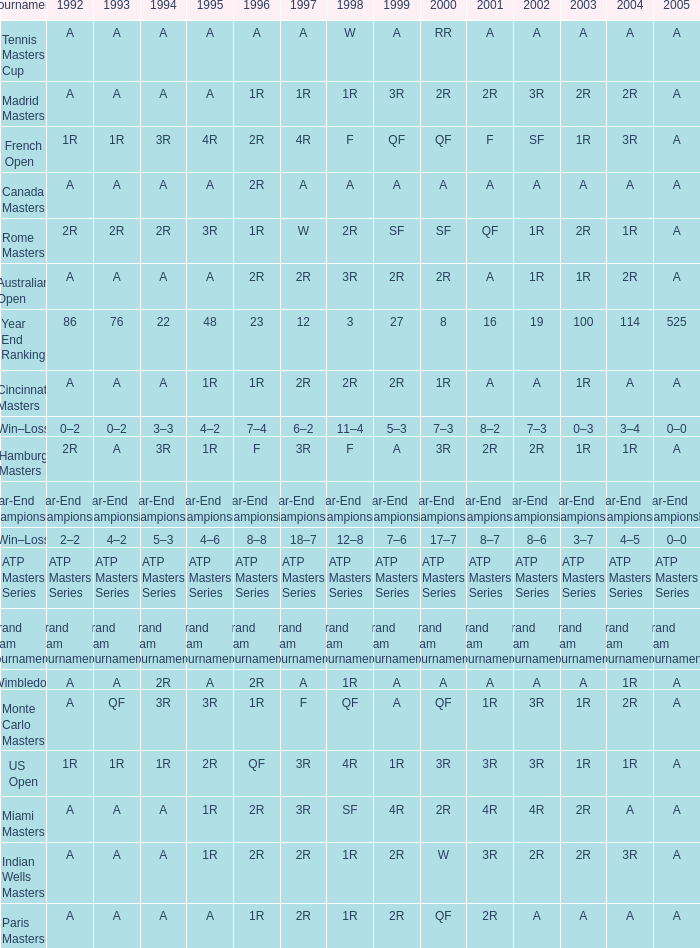What is Tournament, when 2000 is "A"? Wimbledon, Canada Masters. 